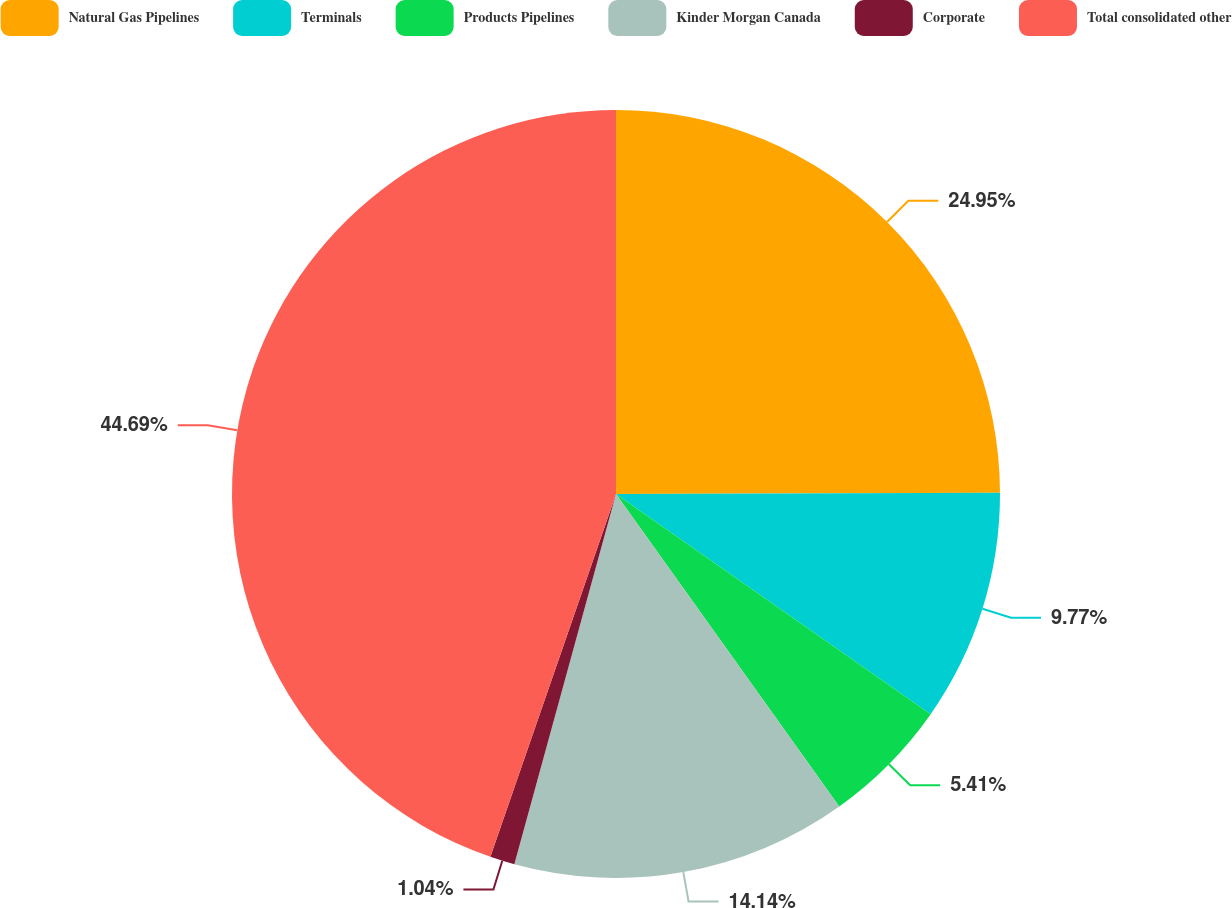Convert chart to OTSL. <chart><loc_0><loc_0><loc_500><loc_500><pie_chart><fcel>Natural Gas Pipelines<fcel>Terminals<fcel>Products Pipelines<fcel>Kinder Morgan Canada<fcel>Corporate<fcel>Total consolidated other<nl><fcel>24.95%<fcel>9.77%<fcel>5.41%<fcel>14.14%<fcel>1.04%<fcel>44.7%<nl></chart> 